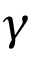Convert formula to latex. <formula><loc_0><loc_0><loc_500><loc_500>\gamma</formula> 